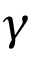Convert formula to latex. <formula><loc_0><loc_0><loc_500><loc_500>\gamma</formula> 